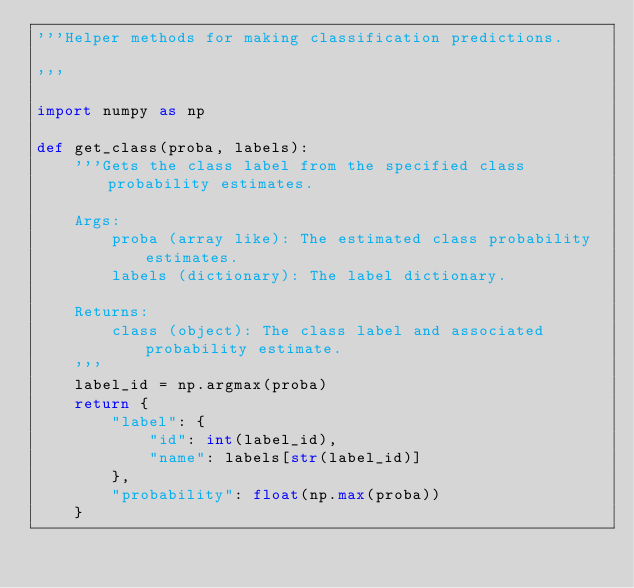<code> <loc_0><loc_0><loc_500><loc_500><_Python_>'''Helper methods for making classification predictions.

'''

import numpy as np

def get_class(proba, labels):
    '''Gets the class label from the specified class probability estimates.

    Args:
        proba (array like): The estimated class probability estimates.
        labels (dictionary): The label dictionary.

    Returns:
        class (object): The class label and associated probability estimate.
    '''
    label_id = np.argmax(proba)
    return {
        "label": {
            "id": int(label_id),
            "name": labels[str(label_id)]
        },
        "probability": float(np.max(proba))
    }
</code> 